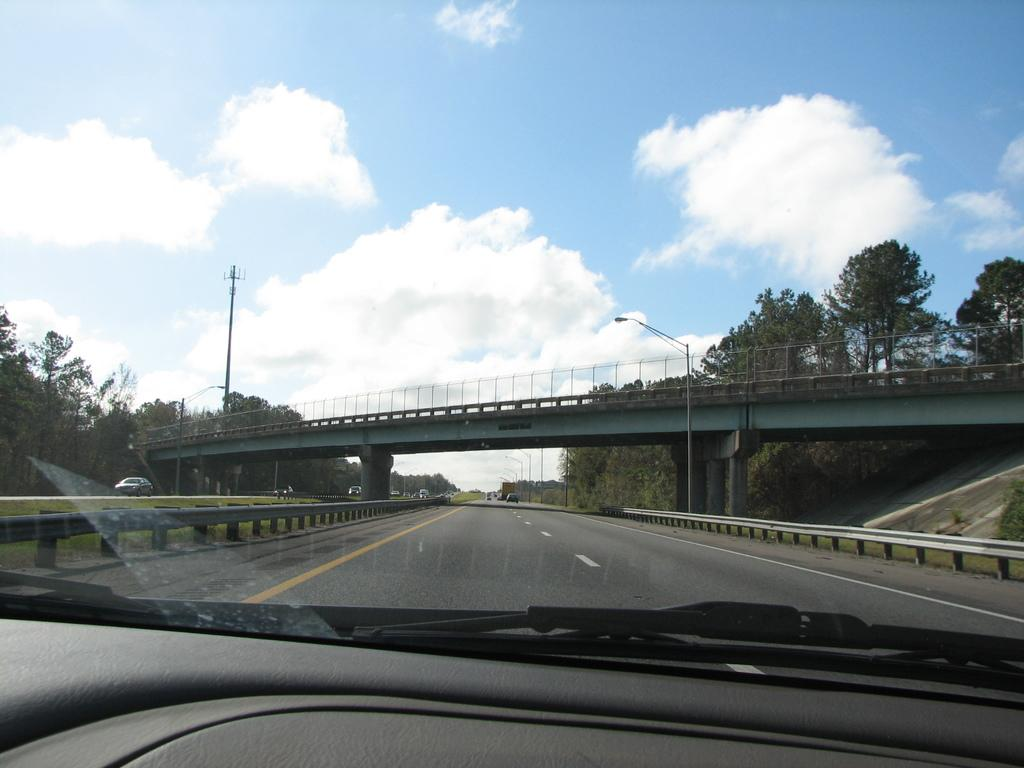What type of natural elements can be seen in the image? There are trees in the image. What man-made structure is present in the image? There is a bridge in the image. What are the light poles used for in the image? The light poles are used for illumination in the image. What type of transportation is visible in the image? There are vehicles in the image. What is the color of the sky in the image? The sky is blue and white in color. What type of cart is being used to perform addition in the image? There is no cart or addition being performed in the image. How does the memory of the trees affect the color of the sky in the image? The image does not depict any memory or its effect on the sky's color; the sky is simply blue and white. 